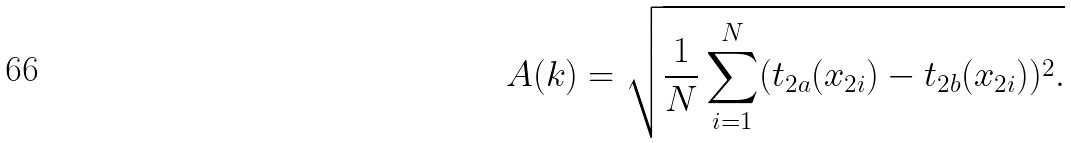<formula> <loc_0><loc_0><loc_500><loc_500>A ( k ) = \sqrt { \frac { 1 } { N } \sum _ { i = 1 } ^ { N } ( t _ { 2 a } ( x _ { 2 i } ) - t _ { 2 b } ( x _ { 2 i } ) ) ^ { 2 } . }</formula> 